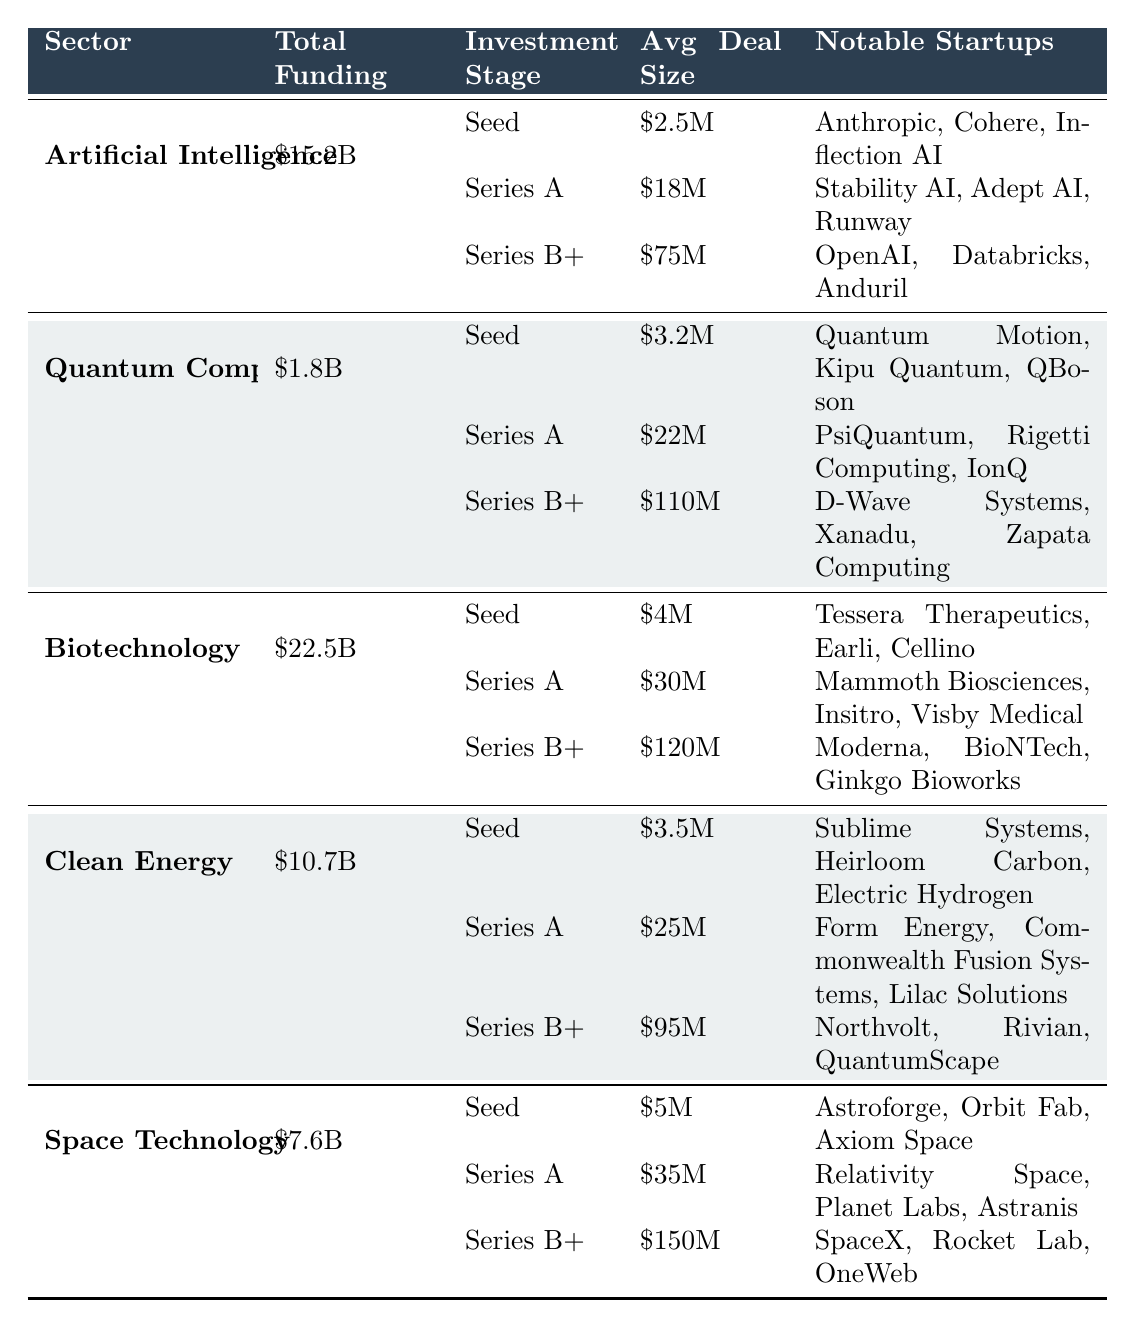What is the total funding for the Biotechnology sector? The total funding amount is clearly listed in the table under the Biotechnology sector, which is $22.5B.
Answer: $22.5B Which investment stage in the Clean Energy sector has the highest average deal size? By comparing the average deal sizes across the investment stages listed under Clean Energy, Series B+ has an average deal size of $95M, which is the highest.
Answer: Series B+ What is the average deal size for the Seed stage across all sectors? The average deal size for Seed stage can be calculated by summing the average deal sizes for Seed across all five sectors: ($2.5M + $3.2M + $4M + $3.5M + $5M) = $18.2M. Then we divide by the number of sectors (5): $18.2M / 5 = $3.64M.
Answer: $3.64M How many deals were made in the Series A stage in total across all sectors? Summing the number of deals for Series A across all sectors provides the total: 156 (AI) + 28 (Quantum) + 210 (Bio) + 140 (Clean) + 75 (Space) = 609 deals.
Answer: 609 deals Is the average deal size for Series B+ in the Quantum Computing sector greater than that in the Clean Energy sector? The average deal size for Quantum Computing's Series B+ is $110M, while for Clean Energy, it is $95M. Since $110M is greater than $95M, the answer is yes.
Answer: Yes What percentage of the total funding for the Artificial Intelligence sector is represented by the Series B+ stage? The total funding for Artificial Intelligence is $15.2B. The Series B+ stage funding can be calculated by multiplying the average deal size by the number of deals: $75M * 84 deals = $6.3B. To find the percentage, use the formula: ($6.3B / $15.2B) * 100 = approximately 41.45%.
Answer: 41.45% What is the notable startup with the highest average deal size in the Space Technology sector? Identifying the average deal size in the Space Technology sector, Series B+ has the highest at $150M, and among notable startups in that stage, SpaceX is listed.
Answer: SpaceX How does the total funding for the Quantum Computing sector compare to that of Clean Energy? The total funding for Quantum Computing is $1.8B and for Clean Energy is $10.7B. Comparing these values, Clean Energy has a higher total funding amount.
Answer: Clean Energy is higher Which sector has the least total funding? By reviewing the total funding amounts listed for each sector, Quantum Computing has the least total funding at $1.8B compared to others.
Answer: Quantum Computing In the Series A stage, which sector has the highest number of deals? The table shows that in Series A, Biotechnology has 210 deals, which is more than any other sector listed in this stage.
Answer: Biotechnology 